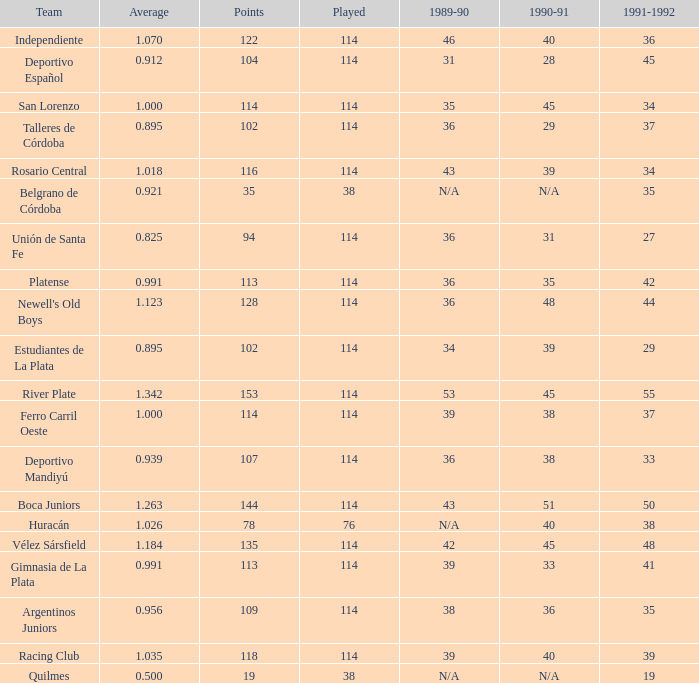I'm looking to parse the entire table for insights. Could you assist me with that? {'header': ['Team', 'Average', 'Points', 'Played', '1989-90', '1990-91', '1991-1992'], 'rows': [['Independiente', '1.070', '122', '114', '46', '40', '36'], ['Deportivo Español', '0.912', '104', '114', '31', '28', '45'], ['San Lorenzo', '1.000', '114', '114', '35', '45', '34'], ['Talleres de Córdoba', '0.895', '102', '114', '36', '29', '37'], ['Rosario Central', '1.018', '116', '114', '43', '39', '34'], ['Belgrano de Córdoba', '0.921', '35', '38', 'N/A', 'N/A', '35'], ['Unión de Santa Fe', '0.825', '94', '114', '36', '31', '27'], ['Platense', '0.991', '113', '114', '36', '35', '42'], ["Newell's Old Boys", '1.123', '128', '114', '36', '48', '44'], ['Estudiantes de La Plata', '0.895', '102', '114', '34', '39', '29'], ['River Plate', '1.342', '153', '114', '53', '45', '55'], ['Ferro Carril Oeste', '1.000', '114', '114', '39', '38', '37'], ['Deportivo Mandiyú', '0.939', '107', '114', '36', '38', '33'], ['Boca Juniors', '1.263', '144', '114', '43', '51', '50'], ['Huracán', '1.026', '78', '76', 'N/A', '40', '38'], ['Vélez Sársfield', '1.184', '135', '114', '42', '45', '48'], ['Gimnasia de La Plata', '0.991', '113', '114', '39', '33', '41'], ['Argentinos Juniors', '0.956', '109', '114', '38', '36', '35'], ['Racing Club', '1.035', '118', '114', '39', '40', '39'], ['Quilmes', '0.500', '19', '38', 'N/A', 'N/A', '19']]} How much Average has a 1989-90 of 36, and a Team of talleres de córdoba, and a Played smaller than 114? 0.0. 